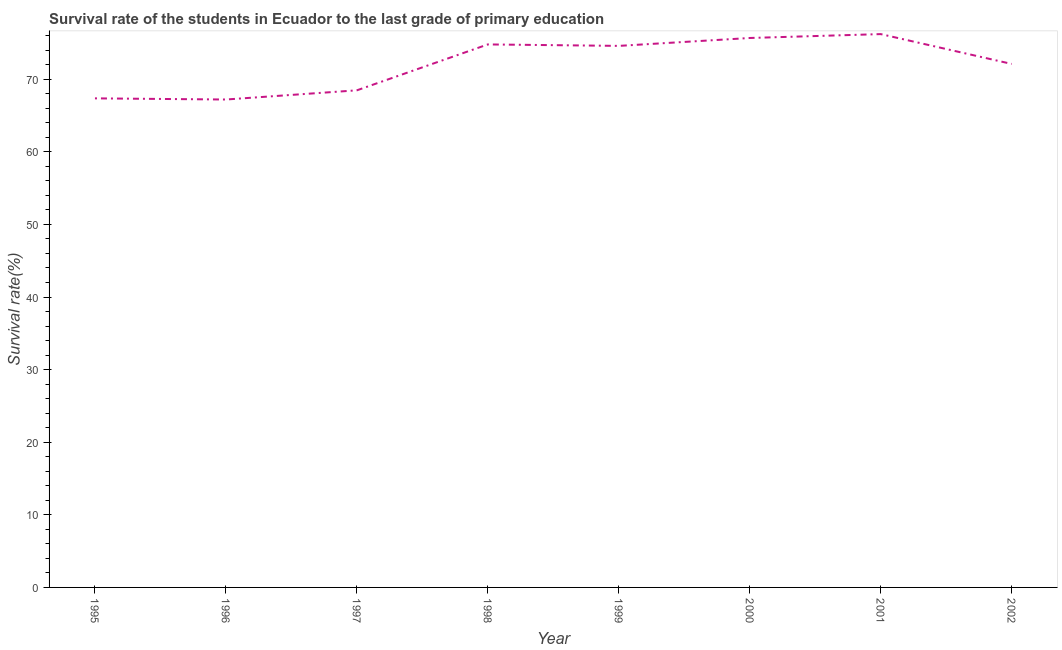What is the survival rate in primary education in 1996?
Provide a short and direct response. 67.2. Across all years, what is the maximum survival rate in primary education?
Keep it short and to the point. 76.21. Across all years, what is the minimum survival rate in primary education?
Give a very brief answer. 67.2. In which year was the survival rate in primary education maximum?
Ensure brevity in your answer.  2001. In which year was the survival rate in primary education minimum?
Make the answer very short. 1996. What is the sum of the survival rate in primary education?
Your answer should be very brief. 576.41. What is the difference between the survival rate in primary education in 1996 and 2001?
Your response must be concise. -9.01. What is the average survival rate in primary education per year?
Provide a short and direct response. 72.05. What is the median survival rate in primary education?
Give a very brief answer. 73.35. Do a majority of the years between 1999 and 1996 (inclusive) have survival rate in primary education greater than 36 %?
Make the answer very short. Yes. What is the ratio of the survival rate in primary education in 2000 to that in 2001?
Your answer should be very brief. 0.99. What is the difference between the highest and the second highest survival rate in primary education?
Your answer should be very brief. 0.54. Is the sum of the survival rate in primary education in 1995 and 2002 greater than the maximum survival rate in primary education across all years?
Your response must be concise. Yes. What is the difference between the highest and the lowest survival rate in primary education?
Offer a very short reply. 9.01. In how many years, is the survival rate in primary education greater than the average survival rate in primary education taken over all years?
Your answer should be very brief. 5. How many lines are there?
Your answer should be compact. 1. How many years are there in the graph?
Offer a very short reply. 8. What is the difference between two consecutive major ticks on the Y-axis?
Ensure brevity in your answer.  10. Are the values on the major ticks of Y-axis written in scientific E-notation?
Make the answer very short. No. Does the graph contain grids?
Keep it short and to the point. No. What is the title of the graph?
Give a very brief answer. Survival rate of the students in Ecuador to the last grade of primary education. What is the label or title of the Y-axis?
Provide a succinct answer. Survival rate(%). What is the Survival rate(%) in 1995?
Your answer should be very brief. 67.36. What is the Survival rate(%) of 1996?
Your answer should be very brief. 67.2. What is the Survival rate(%) in 1997?
Ensure brevity in your answer.  68.47. What is the Survival rate(%) of 1998?
Give a very brief answer. 74.79. What is the Survival rate(%) in 1999?
Make the answer very short. 74.59. What is the Survival rate(%) of 2000?
Your answer should be very brief. 75.68. What is the Survival rate(%) of 2001?
Give a very brief answer. 76.21. What is the Survival rate(%) of 2002?
Offer a terse response. 72.1. What is the difference between the Survival rate(%) in 1995 and 1996?
Your answer should be compact. 0.16. What is the difference between the Survival rate(%) in 1995 and 1997?
Provide a succinct answer. -1.11. What is the difference between the Survival rate(%) in 1995 and 1998?
Ensure brevity in your answer.  -7.43. What is the difference between the Survival rate(%) in 1995 and 1999?
Ensure brevity in your answer.  -7.23. What is the difference between the Survival rate(%) in 1995 and 2000?
Offer a terse response. -8.32. What is the difference between the Survival rate(%) in 1995 and 2001?
Provide a succinct answer. -8.85. What is the difference between the Survival rate(%) in 1995 and 2002?
Ensure brevity in your answer.  -4.74. What is the difference between the Survival rate(%) in 1996 and 1997?
Give a very brief answer. -1.27. What is the difference between the Survival rate(%) in 1996 and 1998?
Offer a very short reply. -7.59. What is the difference between the Survival rate(%) in 1996 and 1999?
Provide a short and direct response. -7.39. What is the difference between the Survival rate(%) in 1996 and 2000?
Keep it short and to the point. -8.47. What is the difference between the Survival rate(%) in 1996 and 2001?
Your answer should be compact. -9.01. What is the difference between the Survival rate(%) in 1996 and 2002?
Make the answer very short. -4.9. What is the difference between the Survival rate(%) in 1997 and 1998?
Make the answer very short. -6.32. What is the difference between the Survival rate(%) in 1997 and 1999?
Offer a very short reply. -6.12. What is the difference between the Survival rate(%) in 1997 and 2000?
Give a very brief answer. -7.21. What is the difference between the Survival rate(%) in 1997 and 2001?
Make the answer very short. -7.74. What is the difference between the Survival rate(%) in 1997 and 2002?
Offer a very short reply. -3.63. What is the difference between the Survival rate(%) in 1998 and 1999?
Offer a terse response. 0.2. What is the difference between the Survival rate(%) in 1998 and 2000?
Offer a terse response. -0.89. What is the difference between the Survival rate(%) in 1998 and 2001?
Make the answer very short. -1.42. What is the difference between the Survival rate(%) in 1998 and 2002?
Provide a succinct answer. 2.69. What is the difference between the Survival rate(%) in 1999 and 2000?
Give a very brief answer. -1.09. What is the difference between the Survival rate(%) in 1999 and 2001?
Your answer should be very brief. -1.62. What is the difference between the Survival rate(%) in 1999 and 2002?
Provide a short and direct response. 2.49. What is the difference between the Survival rate(%) in 2000 and 2001?
Make the answer very short. -0.54. What is the difference between the Survival rate(%) in 2000 and 2002?
Provide a short and direct response. 3.57. What is the difference between the Survival rate(%) in 2001 and 2002?
Your answer should be compact. 4.11. What is the ratio of the Survival rate(%) in 1995 to that in 1996?
Your answer should be very brief. 1. What is the ratio of the Survival rate(%) in 1995 to that in 1998?
Ensure brevity in your answer.  0.9. What is the ratio of the Survival rate(%) in 1995 to that in 1999?
Offer a terse response. 0.9. What is the ratio of the Survival rate(%) in 1995 to that in 2000?
Make the answer very short. 0.89. What is the ratio of the Survival rate(%) in 1995 to that in 2001?
Give a very brief answer. 0.88. What is the ratio of the Survival rate(%) in 1995 to that in 2002?
Make the answer very short. 0.93. What is the ratio of the Survival rate(%) in 1996 to that in 1998?
Offer a very short reply. 0.9. What is the ratio of the Survival rate(%) in 1996 to that in 1999?
Make the answer very short. 0.9. What is the ratio of the Survival rate(%) in 1996 to that in 2000?
Your answer should be very brief. 0.89. What is the ratio of the Survival rate(%) in 1996 to that in 2001?
Your answer should be very brief. 0.88. What is the ratio of the Survival rate(%) in 1996 to that in 2002?
Provide a short and direct response. 0.93. What is the ratio of the Survival rate(%) in 1997 to that in 1998?
Keep it short and to the point. 0.92. What is the ratio of the Survival rate(%) in 1997 to that in 1999?
Keep it short and to the point. 0.92. What is the ratio of the Survival rate(%) in 1997 to that in 2000?
Offer a terse response. 0.91. What is the ratio of the Survival rate(%) in 1997 to that in 2001?
Your response must be concise. 0.9. What is the ratio of the Survival rate(%) in 1997 to that in 2002?
Provide a short and direct response. 0.95. What is the ratio of the Survival rate(%) in 1998 to that in 1999?
Make the answer very short. 1. What is the ratio of the Survival rate(%) in 1998 to that in 2000?
Ensure brevity in your answer.  0.99. What is the ratio of the Survival rate(%) in 1998 to that in 2002?
Ensure brevity in your answer.  1.04. What is the ratio of the Survival rate(%) in 1999 to that in 2000?
Provide a short and direct response. 0.99. What is the ratio of the Survival rate(%) in 1999 to that in 2002?
Make the answer very short. 1.03. What is the ratio of the Survival rate(%) in 2000 to that in 2002?
Offer a very short reply. 1.05. What is the ratio of the Survival rate(%) in 2001 to that in 2002?
Your answer should be very brief. 1.06. 